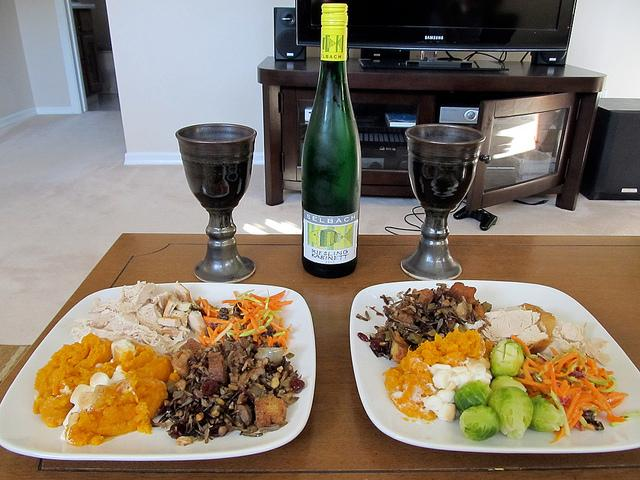Where in the house are they likely planning to dine? Please explain your reasoning. living room. Their food is on the coffee table in front of the tv. 